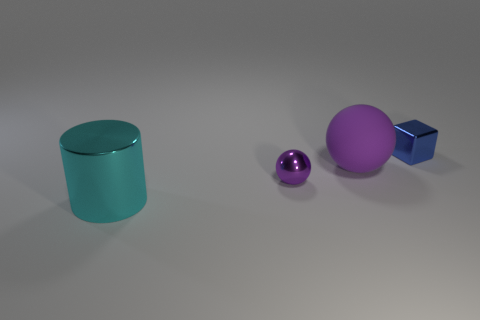Add 1 small purple shiny spheres. How many objects exist? 5 Subtract all cylinders. How many objects are left? 3 Subtract 1 cubes. How many cubes are left? 0 Subtract all big yellow rubber balls. Subtract all big metal cylinders. How many objects are left? 3 Add 4 shiny blocks. How many shiny blocks are left? 5 Add 1 big cyan shiny cylinders. How many big cyan shiny cylinders exist? 2 Subtract 0 gray blocks. How many objects are left? 4 Subtract all gray cubes. Subtract all cyan cylinders. How many cubes are left? 1 